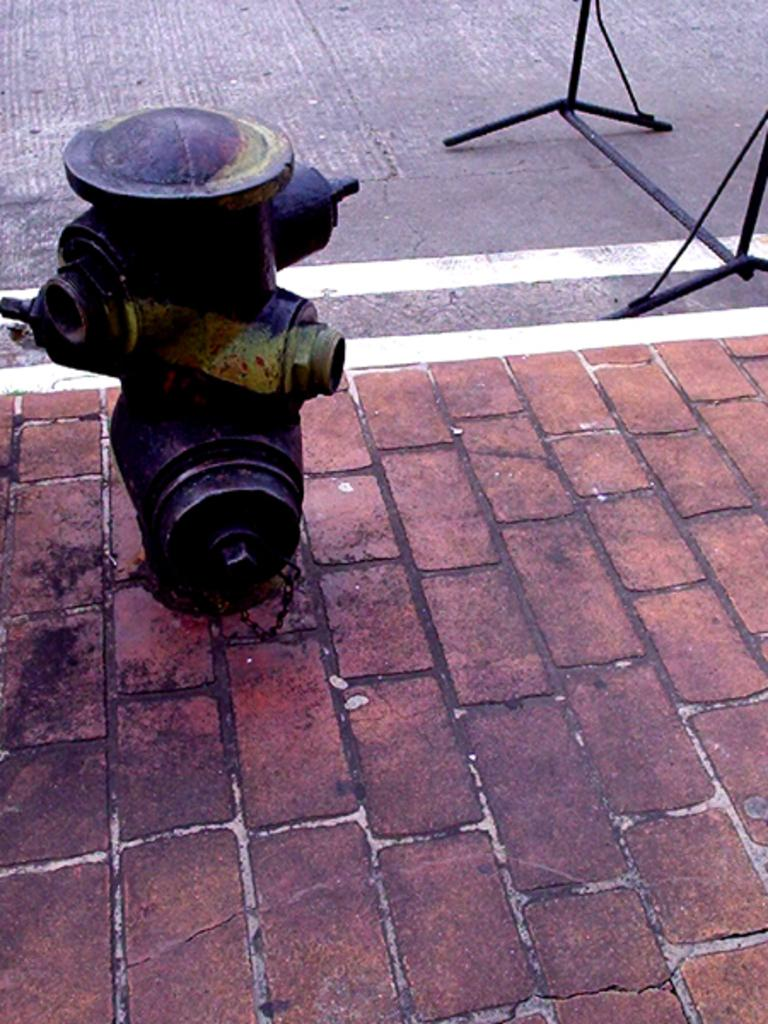What object is located in the image? There is a fire hydrant in the image. Where is the fire hydrant situated? The fire hydrant is on the footpath. What type of surface is visible in the image? There is a road visible in the image. How does the fire hydrant make you feel in the image? The image does not convey any feelings or emotions; it is an inanimate object. What type of carriage is being pulled by a horse in the image? There is no carriage or horse present in the image. 